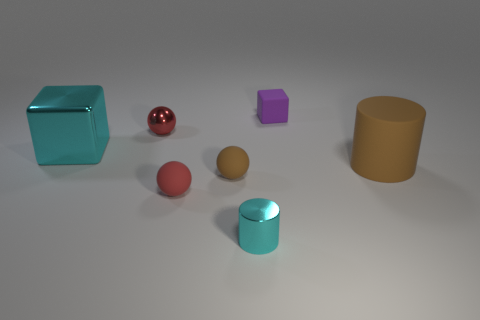Is the brown cylinder made of the same material as the tiny brown ball?
Your response must be concise. Yes. There is a tiny thing that is the same color as the large block; what is its shape?
Your answer should be very brief. Cylinder. There is a small metallic object behind the brown sphere; is it the same color as the tiny metallic cylinder?
Ensure brevity in your answer.  No. There is a tiny matte thing on the right side of the shiny cylinder; what number of small purple matte cubes are to the right of it?
Offer a very short reply. 0. There is a shiny ball that is the same size as the purple matte cube; what is its color?
Keep it short and to the point. Red. What is the small thing in front of the small red matte sphere made of?
Your answer should be compact. Metal. There is a object that is both in front of the big cyan cube and to the right of the cyan cylinder; what material is it made of?
Your answer should be very brief. Rubber. There is a red object that is behind the brown matte sphere; does it have the same size as the big brown matte object?
Your answer should be very brief. No. There is a big matte object; what shape is it?
Your answer should be very brief. Cylinder. What number of big green matte things are the same shape as the red matte object?
Make the answer very short. 0. 